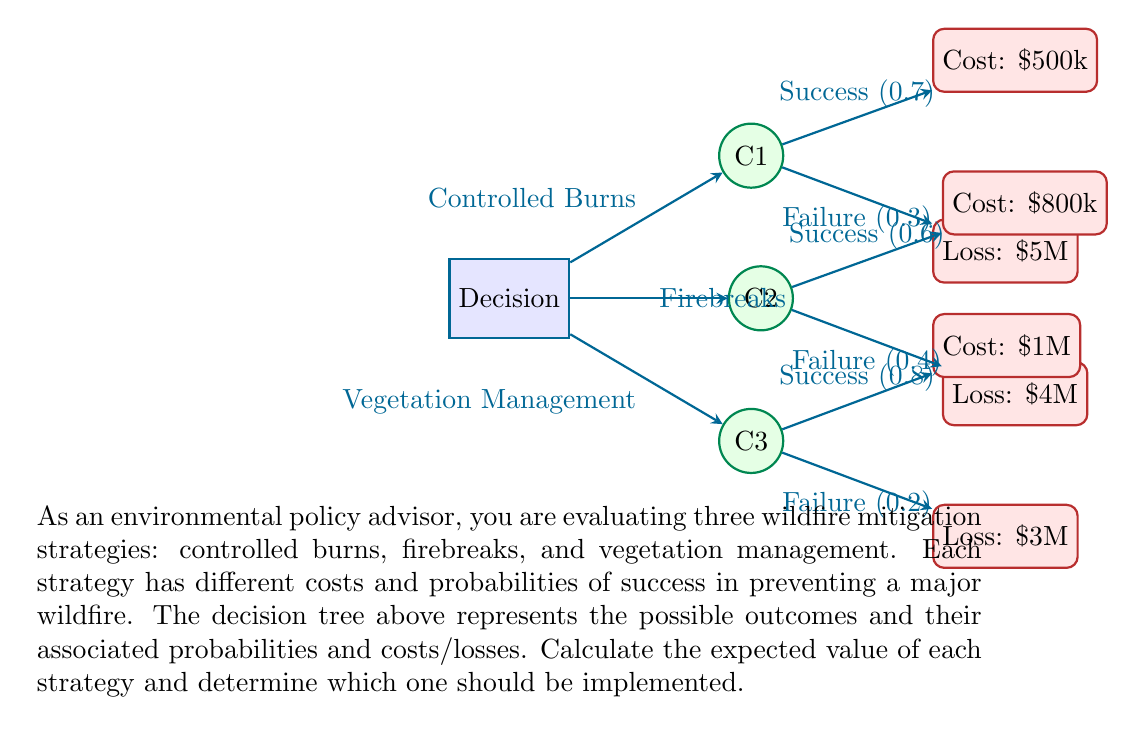Provide a solution to this math problem. To calculate the expected value of each strategy, we need to follow these steps:

1. Calculate the expected value of each outcome (success and failure) for each strategy.
2. Sum the expected values for each strategy.
3. Compare the results to determine the best strategy.

Let's calculate for each strategy:

1. Controlled Burns:
   Success: $0.7 \times (-\$500,000) = -\$350,000$
   Failure: $0.3 \times (-\$5,000,000) = -\$1,500,000$
   Expected Value: $-\$350,000 + (-\$1,500,000) = -\$1,850,000$

2. Firebreaks:
   Success: $0.6 \times (-\$800,000) = -\$480,000$
   Failure: $0.4 \times (-\$4,000,000) = -\$1,600,000$
   Expected Value: $-\$480,000 + (-\$1,600,000) = -\$2,080,000$

3. Vegetation Management:
   Success: $0.8 \times (-\$1,000,000) = -\$800,000$
   Failure: $0.2 \times (-\$3,000,000) = -\$600,000$
   Expected Value: $-\$800,000 + (-\$600,000) = -\$1,400,000$

The expected values for each strategy are:
- Controlled Burns: $-\$1,850,000$
- Firebreaks: $-\$2,080,000$
- Vegetation Management: $-\$1,400,000$

The strategy with the highest (least negative) expected value should be implemented, which is Vegetation Management with an expected value of $-\$1,400,000$.
Answer: Vegetation Management, $-\$1,400,000$ 